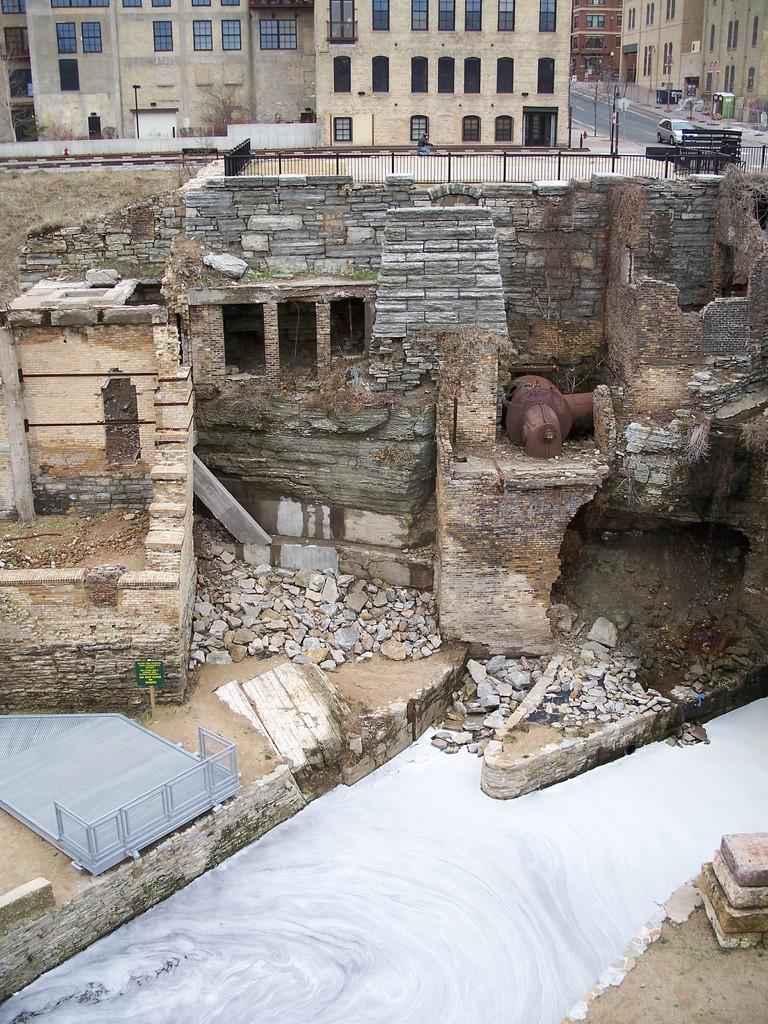Could you give a brief overview of what you see in this image? In this image we can see there are buildings, poles and boxes. And there is the car on the road. In front of the building there is a fence and destructed building. We can see there are stones, water and metal object. 